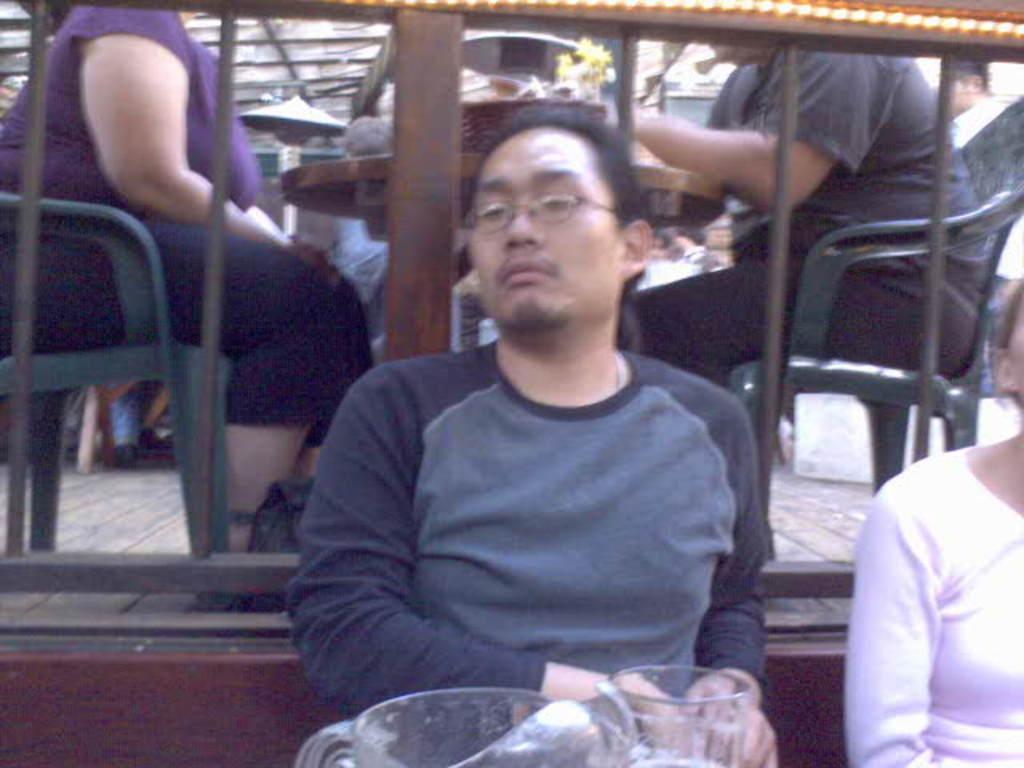Please provide a concise description of this image. In this image we can see some people sitting on the chairs and a table containing a basket and some objects on it. We can also see a roof. In the foreground we can see the railing, some people, a glass jar and a glass. 